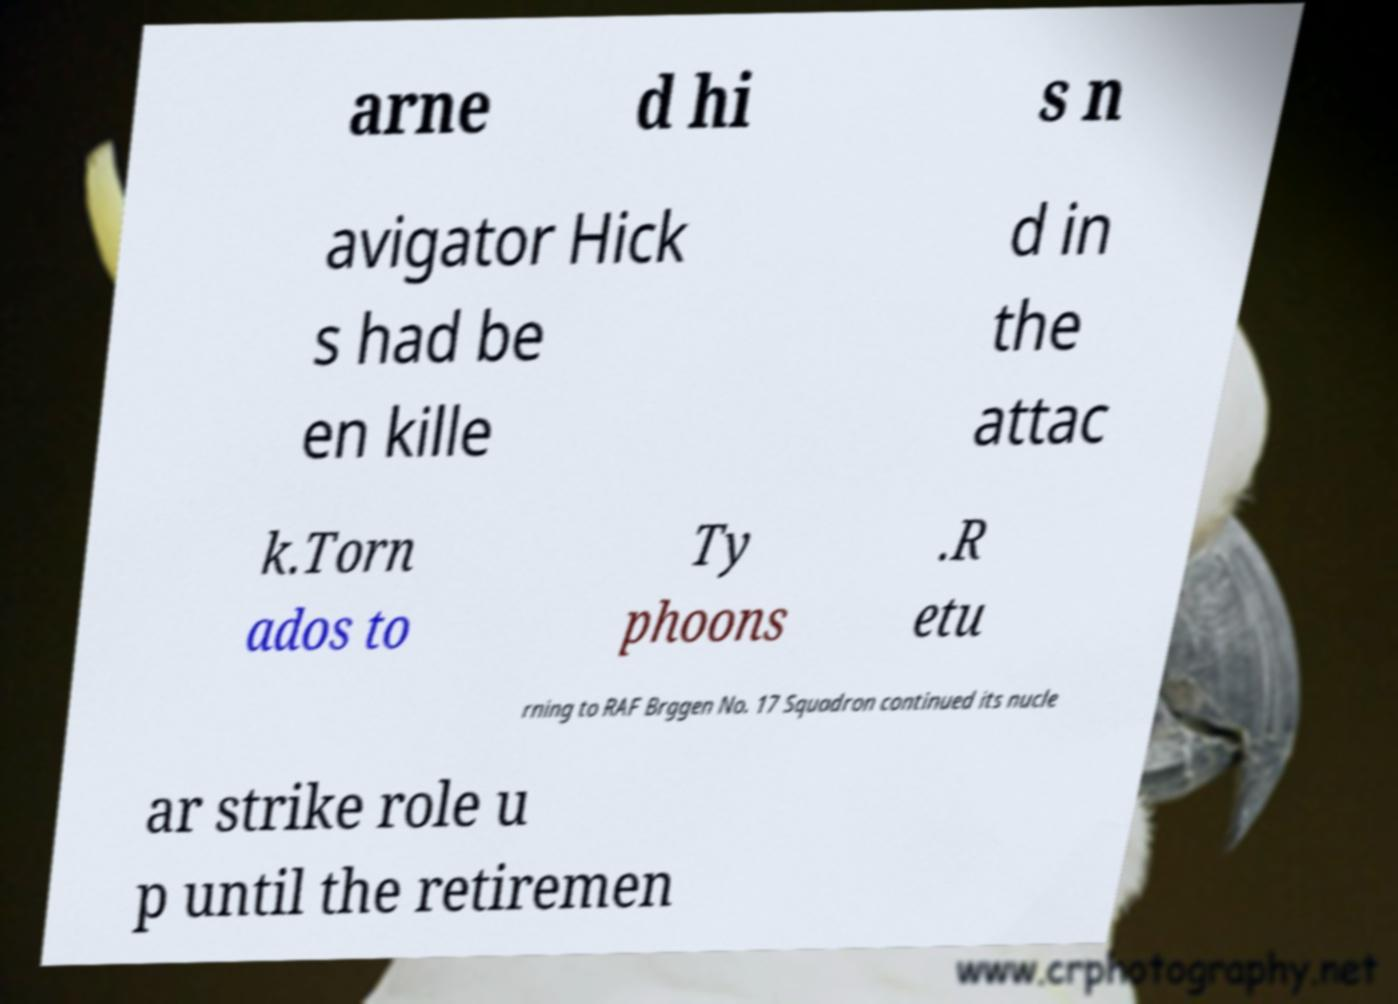Could you assist in decoding the text presented in this image and type it out clearly? arne d hi s n avigator Hick s had be en kille d in the attac k.Torn ados to Ty phoons .R etu rning to RAF Brggen No. 17 Squadron continued its nucle ar strike role u p until the retiremen 